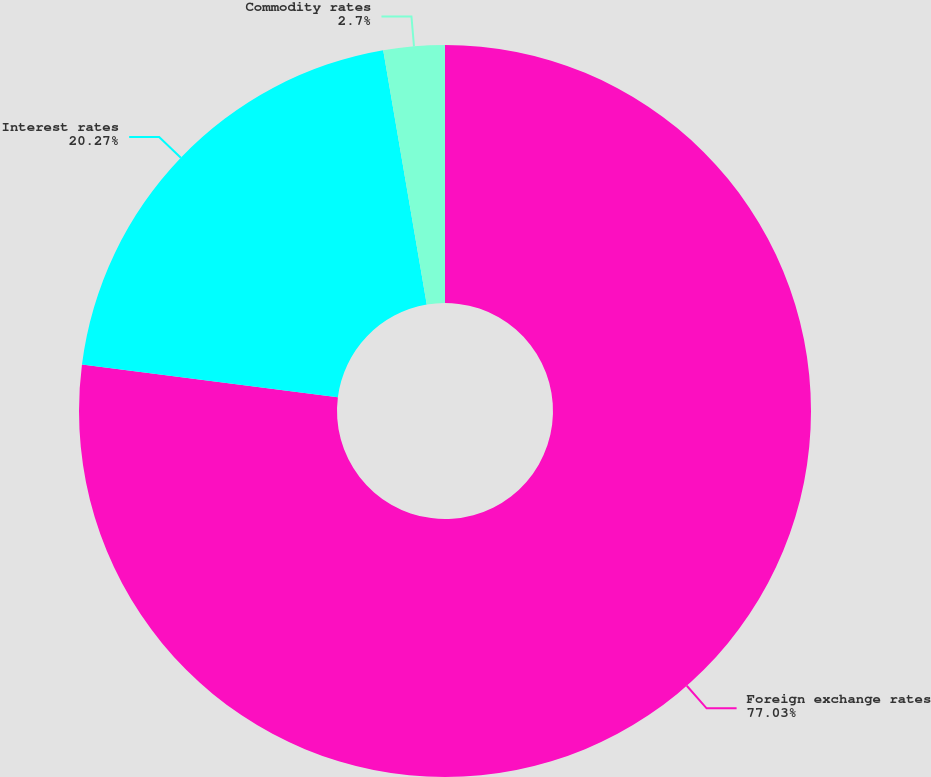Convert chart to OTSL. <chart><loc_0><loc_0><loc_500><loc_500><pie_chart><fcel>Foreign exchange rates<fcel>Interest rates<fcel>Commodity rates<nl><fcel>77.03%<fcel>20.27%<fcel>2.7%<nl></chart> 